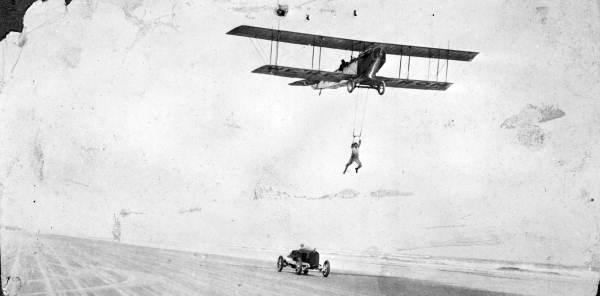Are the planes in the air?
Write a very short answer. Yes. Around which decade could this picture have taken place?
Keep it brief. 1930s. How many people are hanging from the plane?
Quick response, please. 1. Is this photo in black and white?
Answer briefly. Yes. What is this person riding?
Answer briefly. Plane. What is the person riding?
Keep it brief. Airplane. 